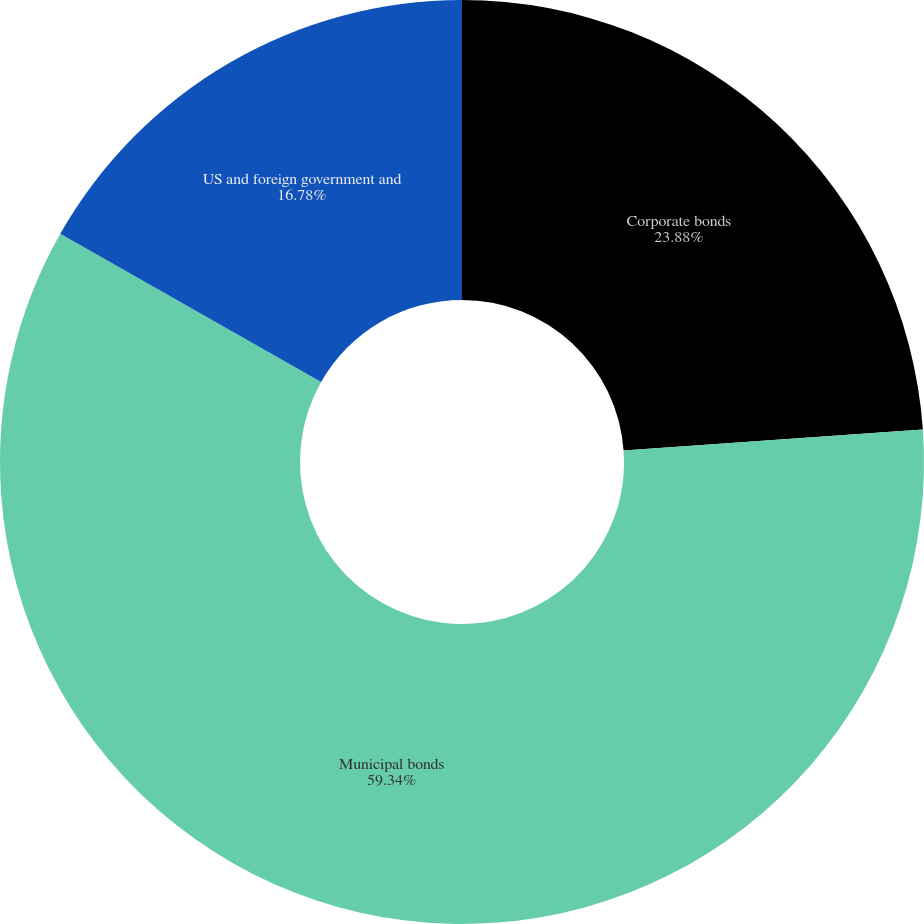Convert chart. <chart><loc_0><loc_0><loc_500><loc_500><pie_chart><fcel>Corporate bonds<fcel>Municipal bonds<fcel>US and foreign government and<nl><fcel>23.88%<fcel>59.34%<fcel>16.78%<nl></chart> 